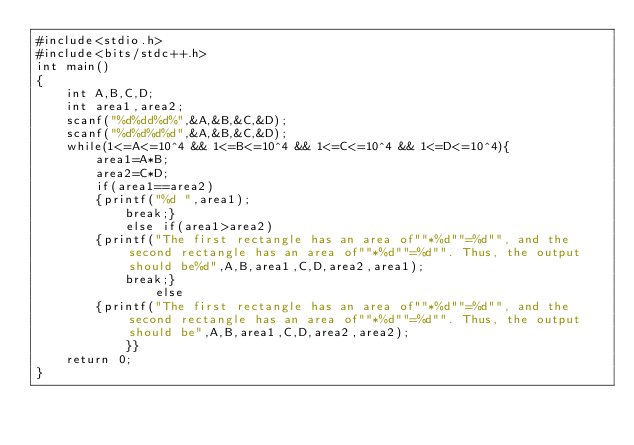<code> <loc_0><loc_0><loc_500><loc_500><_C++_>#include<stdio.h>
#include<bits/stdc++.h> 
int main()
{
	int A,B,C,D;
	int area1,area2;
	scanf("%d%dd%d%",&A,&B,&C,&D);
	scanf("%d%d%d%d",&A,&B,&C,&D);
	while(1<=A<=10^4 && 1<=B<=10^4 && 1<=C<=10^4 && 1<=D<=10^4){
		area1=A*B;
		area2=C*D;
		if(area1==area2)
		{printf("%d ",area1);
			break;}
			else if(area1>area2)
		{printf("The first rectangle has an area of""*%d""=%d"", and the second rectangle has an area of""*%d""=%d"". Thus, the output should be%d",A,B,area1,C,D,area2,area1);
		    break;}
				else
		{printf("The first rectangle has an area of""*%d""=%d"", and the second rectangle has an area of""*%d""=%d"". Thus, the output should be",A,B,area1,C,D,area2,area2);
			}}
	return 0;
}</code> 